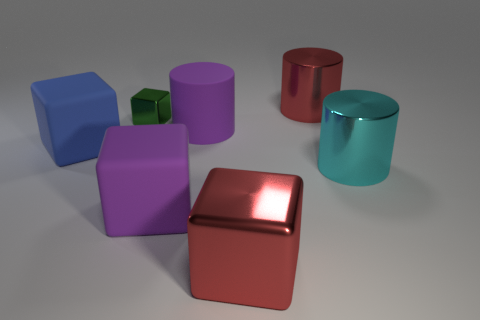Add 1 large red metal cubes. How many objects exist? 8 Subtract all blocks. How many objects are left? 3 Subtract 0 brown cubes. How many objects are left? 7 Subtract all blue metal cylinders. Subtract all big blue matte things. How many objects are left? 6 Add 2 red metal blocks. How many red metal blocks are left? 3 Add 4 big blue rubber objects. How many big blue rubber objects exist? 5 